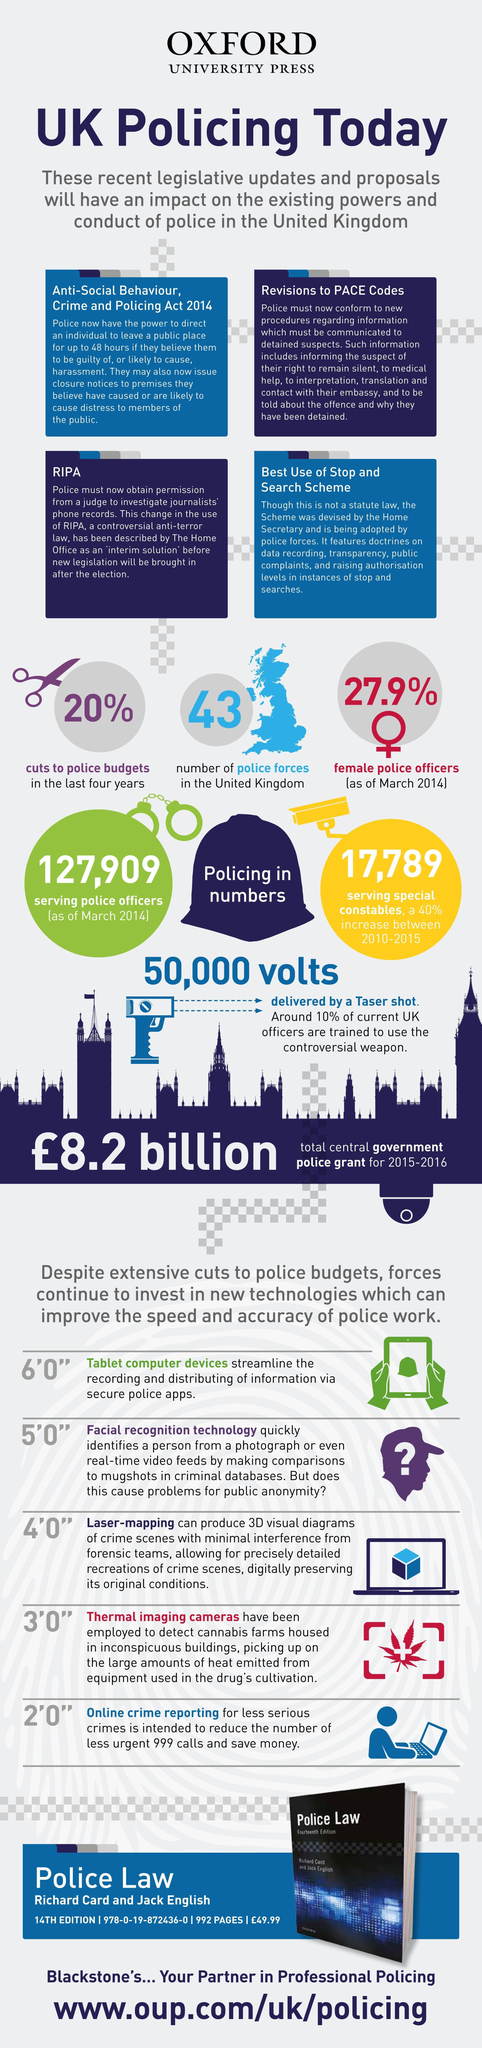What is the cost of the book in pounds shown in the infographic?
Answer the question with a short phrase. 49.99 What percentage of police officers in UK are not women? 72.1 What is the total number of police officers in UK? 127,909 What percentage of UK police are not trained to use Taser shot? 90 What is the strength of Police force in UK? 43 Which is the major weapon used by UK Police? Taser shot 